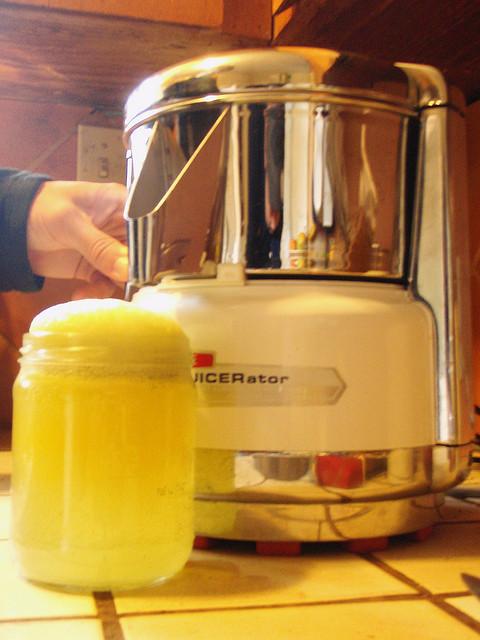What brand of juicer is this?
Be succinct. Juicerator. What is this?
Quick response, please. Juicer. What color is the tile on the table?
Short answer required. Yellow. 